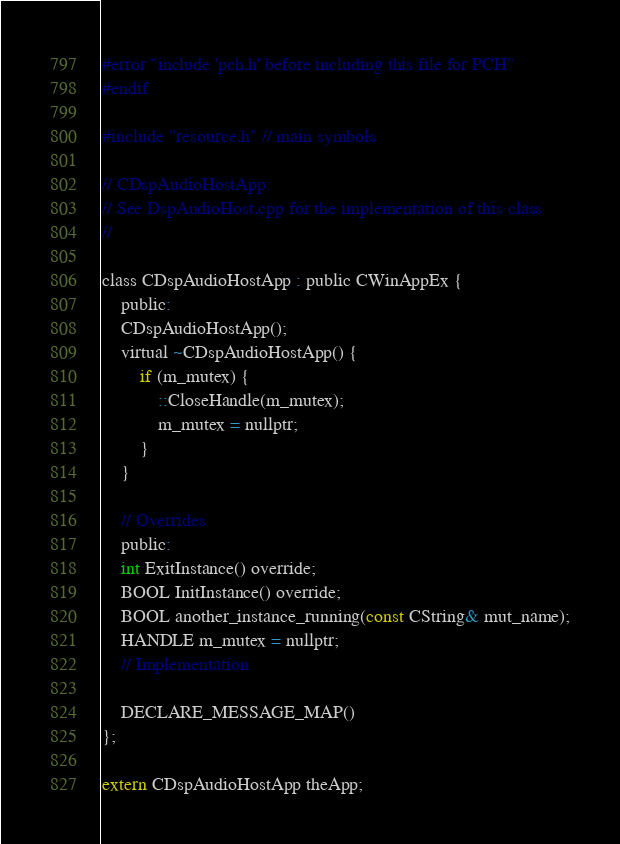<code> <loc_0><loc_0><loc_500><loc_500><_C_>#error "include 'pch.h' before including this file for PCH"
#endif

#include "resource.h" // main symbols

// CDspAudioHostApp:
// See DspAudioHost.cpp for the implementation of this class
//

class CDspAudioHostApp : public CWinAppEx {
    public:
    CDspAudioHostApp();
    virtual ~CDspAudioHostApp() {
        if (m_mutex) {
            ::CloseHandle(m_mutex);
            m_mutex = nullptr;
        }
    }

    // Overrides
    public:
    int ExitInstance() override;
    BOOL InitInstance() override;
    BOOL another_instance_running(const CString& mut_name);
    HANDLE m_mutex = nullptr;
    // Implementation

    DECLARE_MESSAGE_MAP()
};

extern CDspAudioHostApp theApp;
</code> 